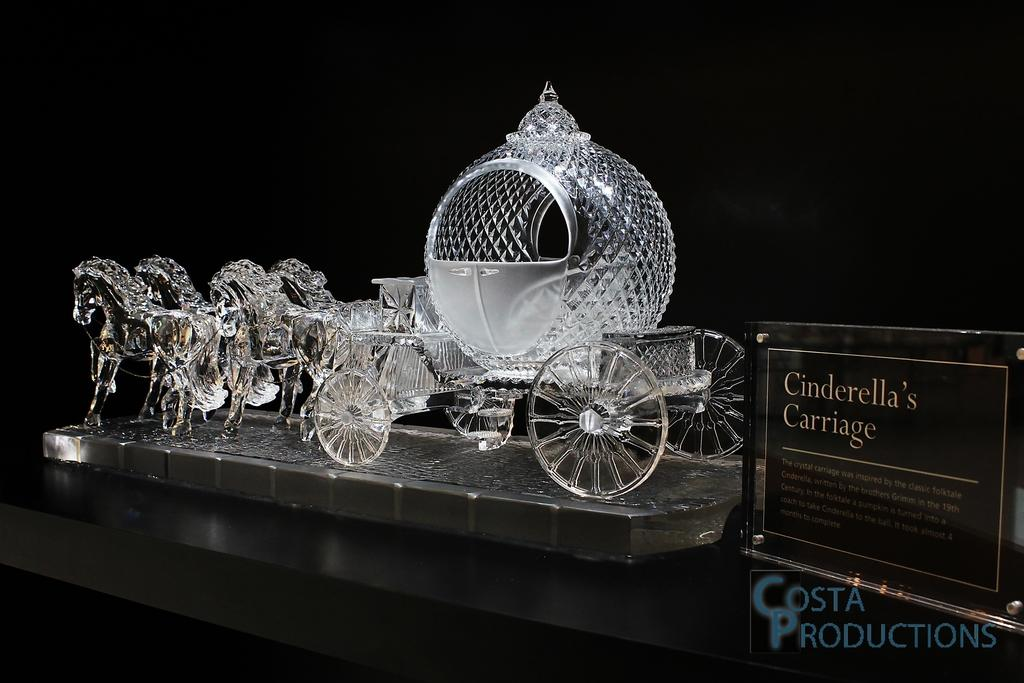What is the main subject of the image? There is a Cinderella carriage made of glass in the image. Where is the carriage located? The carriage is placed on a table. What is on the right side of the image? There is a black color board on the right side of the image. What can be seen on the black color board? Text is visible on the black color board. What event is being advertised on the wheel in the image? There is no wheel present in the image, and therefore no event can be advertised on it. 